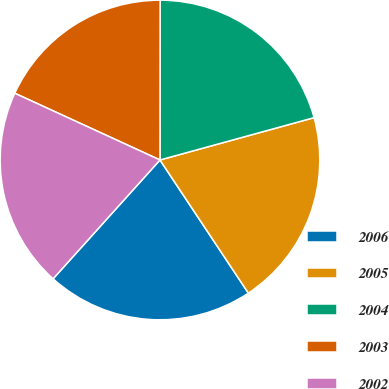Convert chart to OTSL. <chart><loc_0><loc_0><loc_500><loc_500><pie_chart><fcel>2006<fcel>2005<fcel>2004<fcel>2003<fcel>2002<nl><fcel>20.99%<fcel>19.94%<fcel>20.72%<fcel>18.16%<fcel>20.2%<nl></chart> 